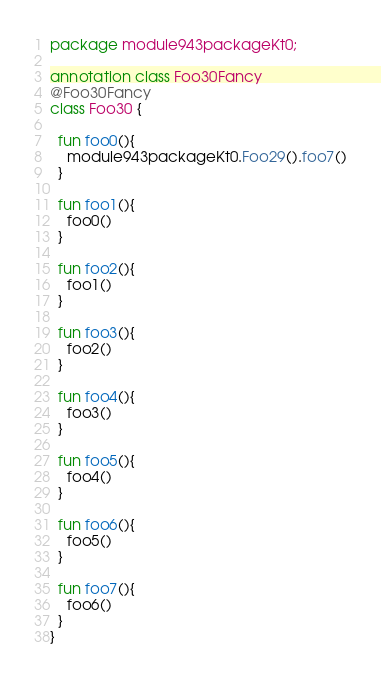<code> <loc_0><loc_0><loc_500><loc_500><_Kotlin_>package module943packageKt0;

annotation class Foo30Fancy
@Foo30Fancy
class Foo30 {

  fun foo0(){
    module943packageKt0.Foo29().foo7()
  }

  fun foo1(){
    foo0()
  }

  fun foo2(){
    foo1()
  }

  fun foo3(){
    foo2()
  }

  fun foo4(){
    foo3()
  }

  fun foo5(){
    foo4()
  }

  fun foo6(){
    foo5()
  }

  fun foo7(){
    foo6()
  }
}</code> 